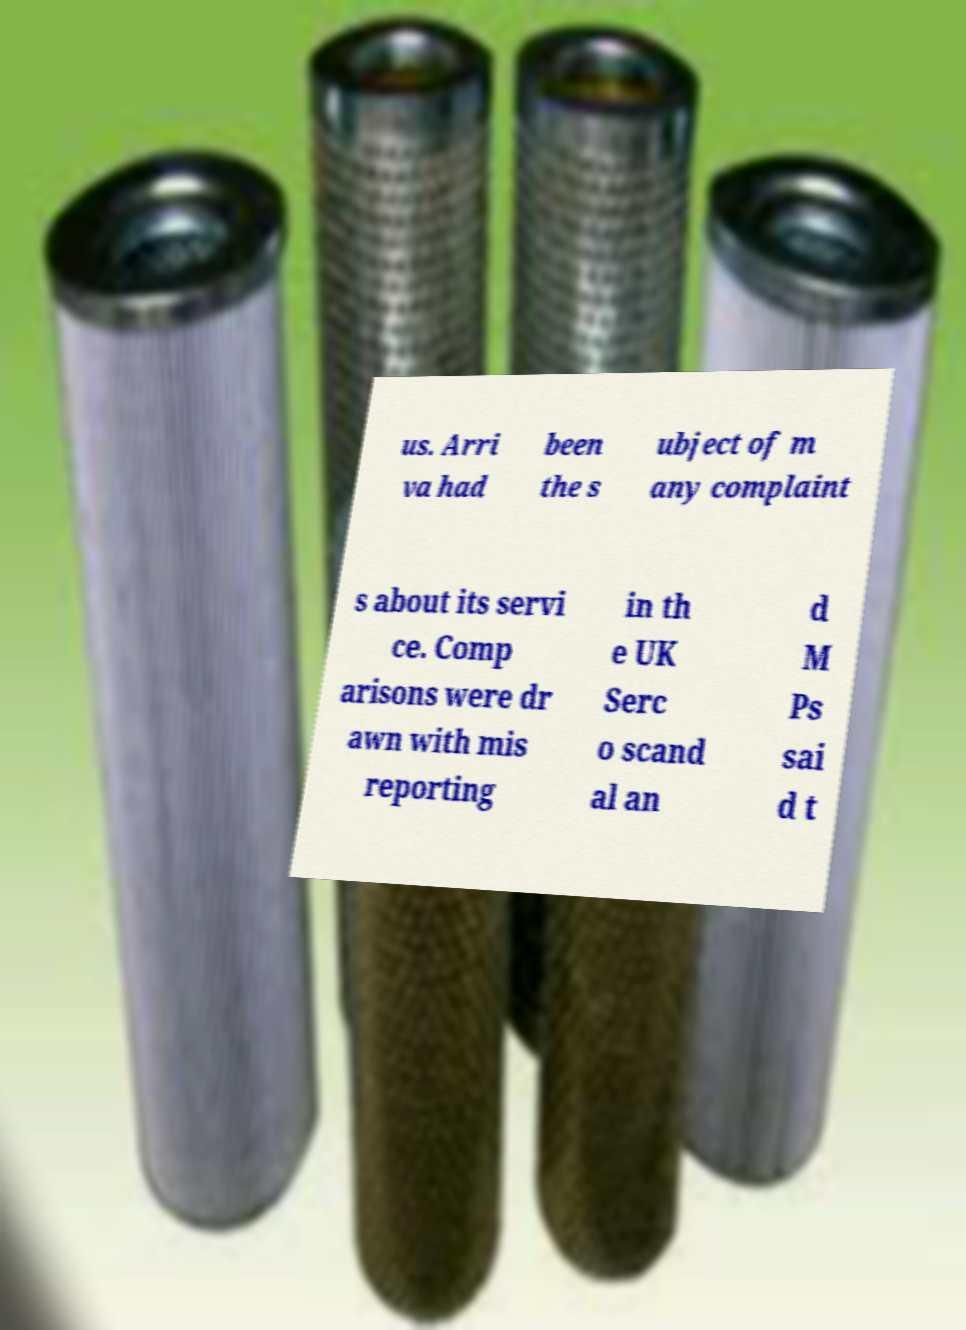What messages or text are displayed in this image? I need them in a readable, typed format. us. Arri va had been the s ubject of m any complaint s about its servi ce. Comp arisons were dr awn with mis reporting in th e UK Serc o scand al an d M Ps sai d t 